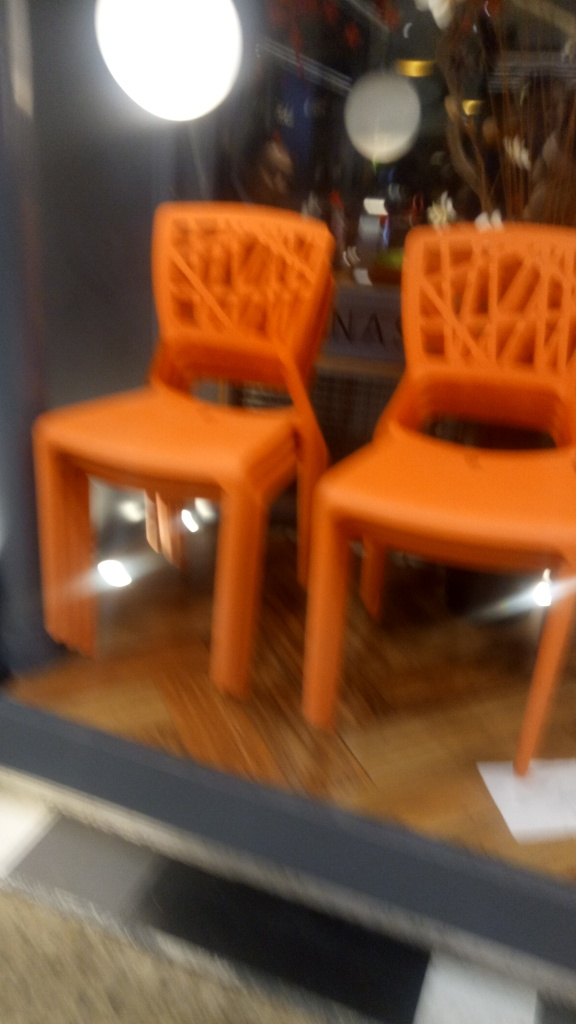What kind of setting does this image depict, and what mood does it convey? The setting appears to be a display inside a store or a showroom, featuring vibrant orange chairs that stand out due to their color. The blurred quality of the image creates a sense of motion or disorientation, potentially conveying a mood of haste or a fleeting moment. 